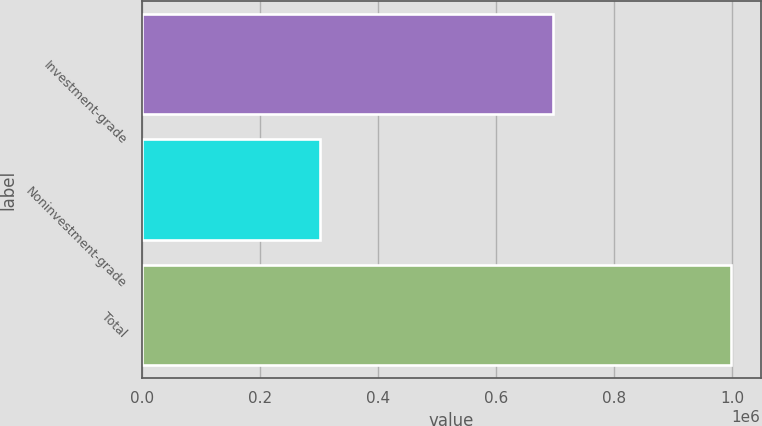Convert chart. <chart><loc_0><loc_0><loc_500><loc_500><bar_chart><fcel>Investment-grade<fcel>Noninvestment-grade<fcel>Total<nl><fcel>696555<fcel>301318<fcel>997873<nl></chart> 